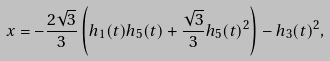Convert formula to latex. <formula><loc_0><loc_0><loc_500><loc_500>x = - \frac { 2 \sqrt { 3 } } { 3 } \left ( h _ { 1 } ( t ) h _ { 5 } ( t ) + \frac { \sqrt { 3 } } { 3 } h _ { 5 } ( t ) ^ { 2 } \right ) - h _ { 3 } ( t ) ^ { 2 } ,</formula> 